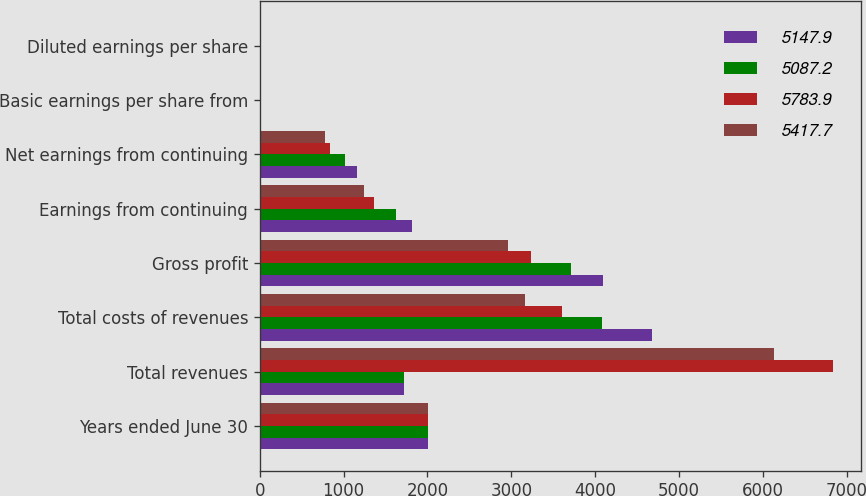<chart> <loc_0><loc_0><loc_500><loc_500><stacked_bar_chart><ecel><fcel>Years ended June 30<fcel>Total revenues<fcel>Total costs of revenues<fcel>Gross profit<fcel>Earnings from continuing<fcel>Net earnings from continuing<fcel>Basic earnings per share from<fcel>Diluted earnings per share<nl><fcel>5147.9<fcel>2008<fcel>1717.75<fcel>4680.1<fcel>4096.4<fcel>1812<fcel>1161.7<fcel>2.23<fcel>2.2<nl><fcel>5087.2<fcel>2007<fcel>1717.75<fcel>4087.3<fcel>3712.7<fcel>1623.5<fcel>1021.2<fcel>1.86<fcel>1.83<nl><fcel>5783.9<fcel>2006<fcel>6835.6<fcel>3603.7<fcel>3231.9<fcel>1361.2<fcel>841.9<fcel>1.46<fcel>1.45<nl><fcel>5417.7<fcel>2005<fcel>6131.3<fcel>3165.3<fcel>2966<fcel>1237.8<fcel>780.6<fcel>1.34<fcel>1.32<nl></chart> 